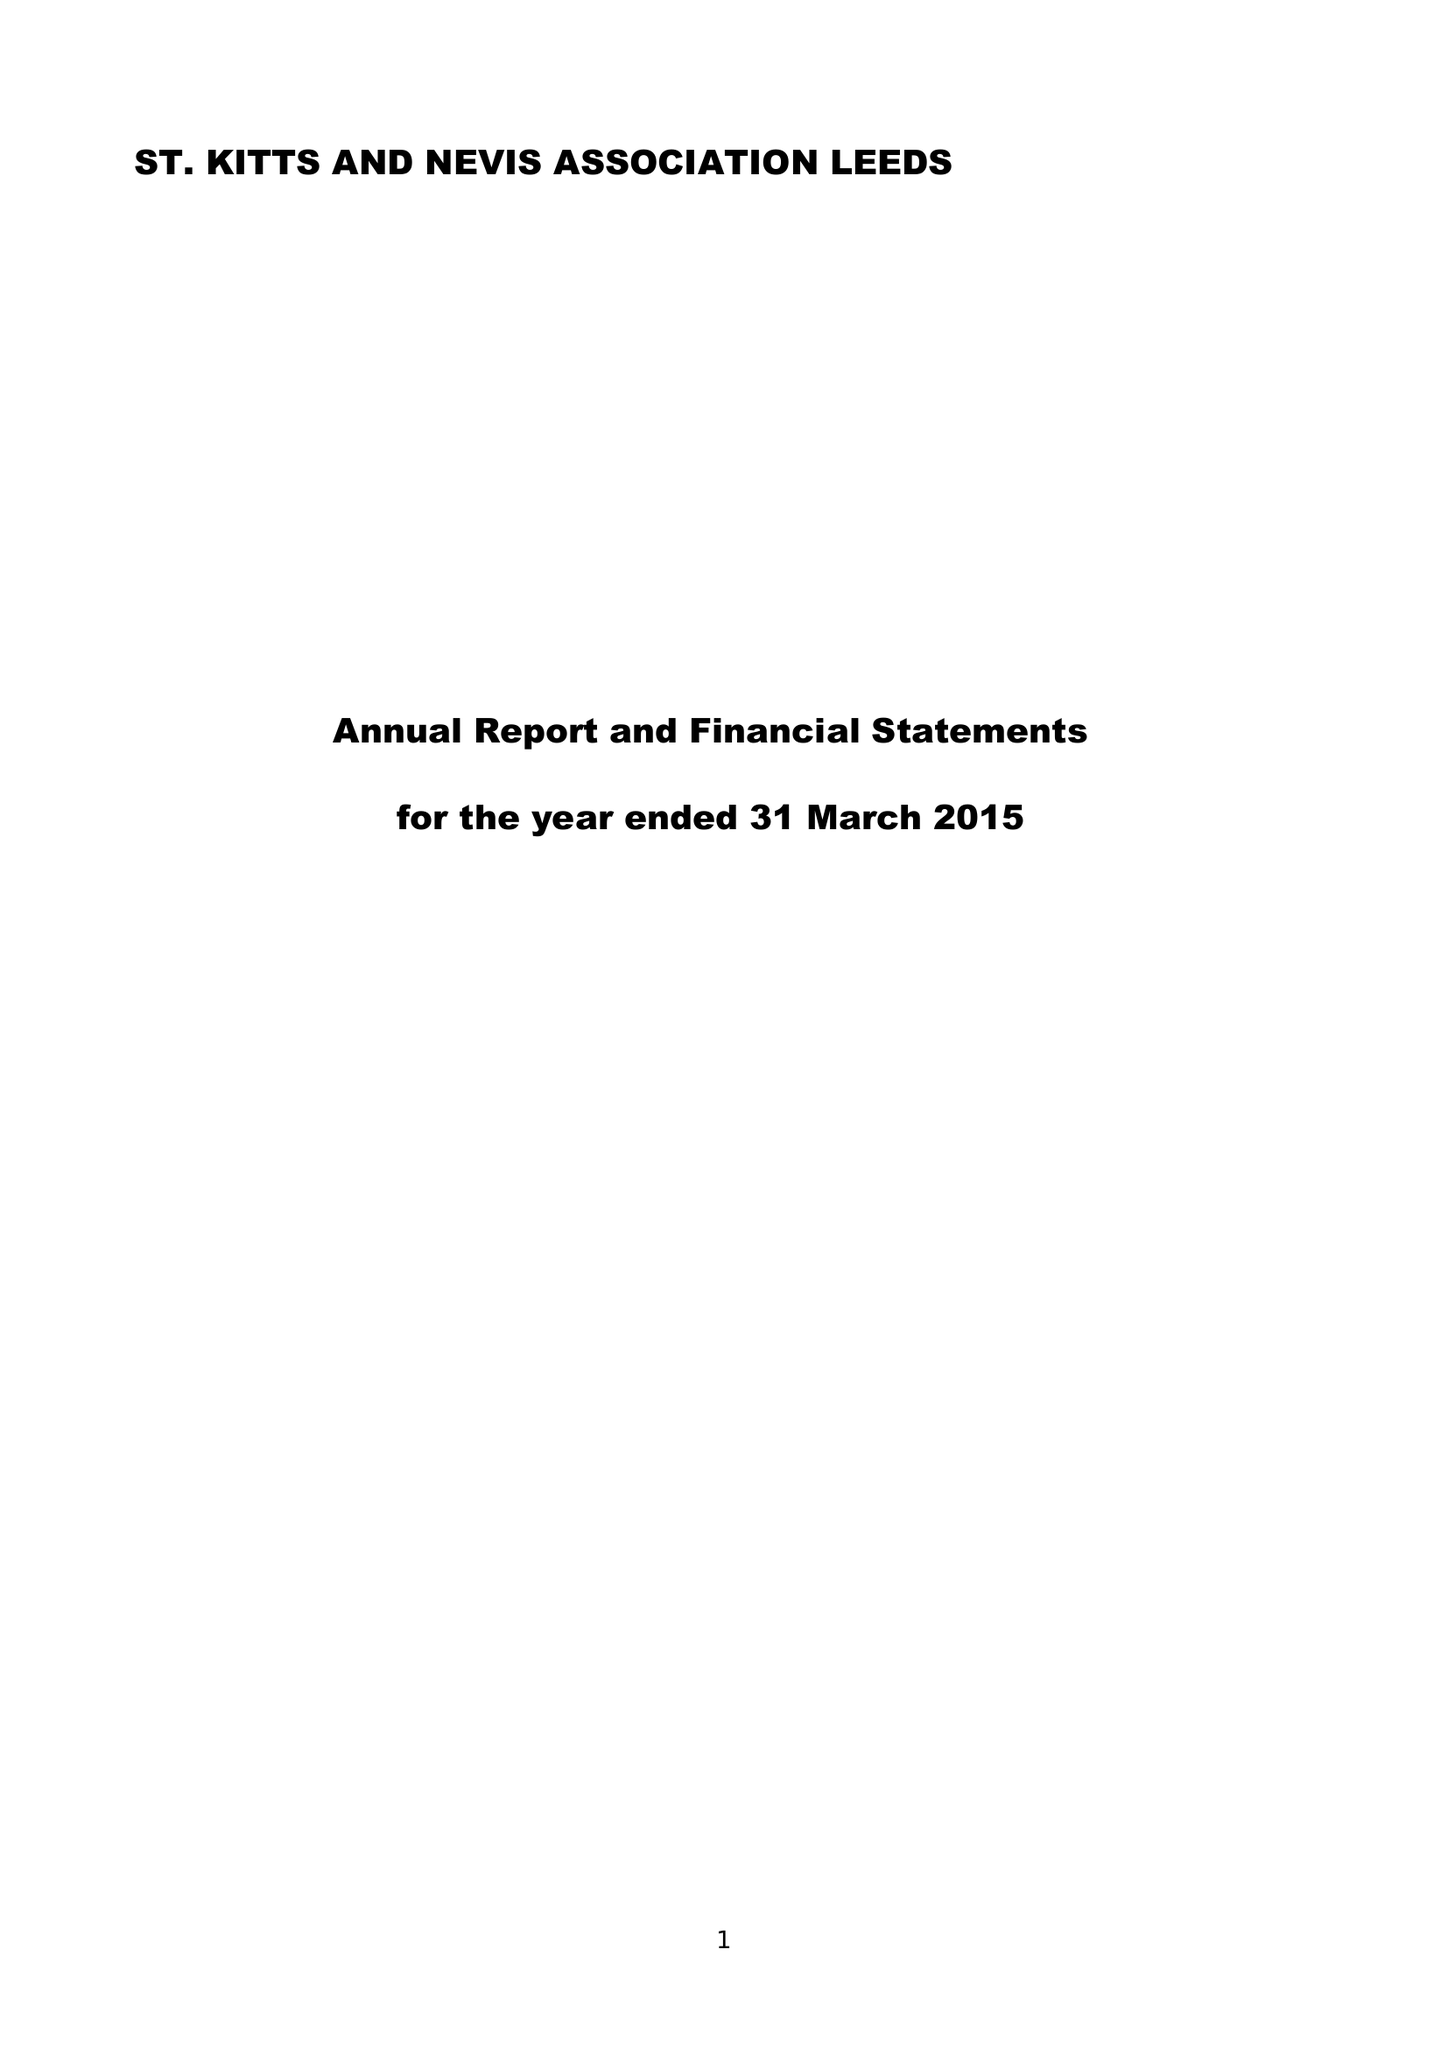What is the value for the charity_name?
Answer the question using a single word or phrase. St Christopher (St Kitts) and Nevis Association (Leeds) 